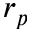<formula> <loc_0><loc_0><loc_500><loc_500>r _ { p }</formula> 